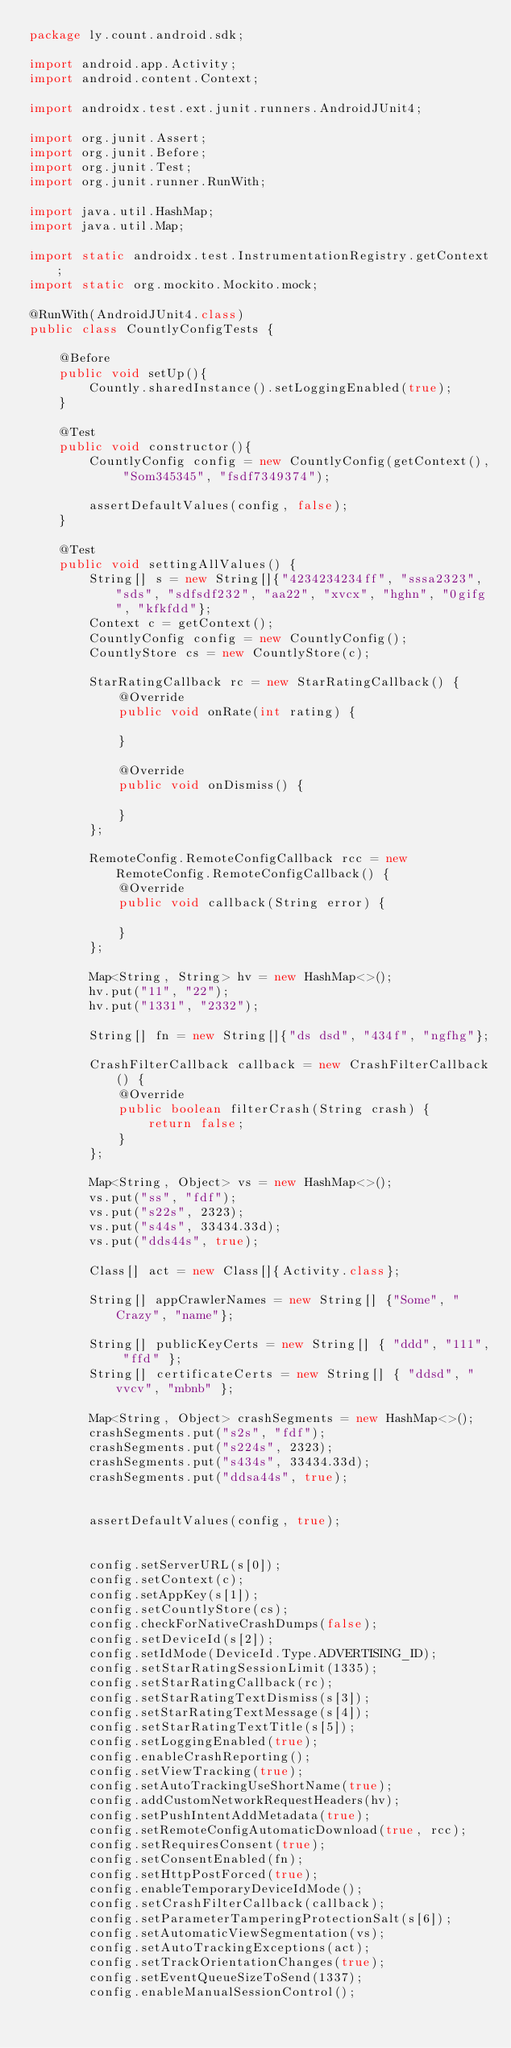Convert code to text. <code><loc_0><loc_0><loc_500><loc_500><_Java_>package ly.count.android.sdk;

import android.app.Activity;
import android.content.Context;

import androidx.test.ext.junit.runners.AndroidJUnit4;

import org.junit.Assert;
import org.junit.Before;
import org.junit.Test;
import org.junit.runner.RunWith;

import java.util.HashMap;
import java.util.Map;

import static androidx.test.InstrumentationRegistry.getContext;
import static org.mockito.Mockito.mock;

@RunWith(AndroidJUnit4.class)
public class CountlyConfigTests {

    @Before
    public void setUp(){
        Countly.sharedInstance().setLoggingEnabled(true);
    }

    @Test
    public void constructor(){
        CountlyConfig config = new CountlyConfig(getContext(), "Som345345", "fsdf7349374");

        assertDefaultValues(config, false);
    }

    @Test
    public void settingAllValues() {
        String[] s = new String[]{"4234234234ff", "sssa2323", "sds", "sdfsdf232", "aa22", "xvcx", "hghn", "0gifg", "kfkfdd"};
        Context c = getContext();
        CountlyConfig config = new CountlyConfig();
        CountlyStore cs = new CountlyStore(c);

        StarRatingCallback rc = new StarRatingCallback() {
            @Override
            public void onRate(int rating) {

            }

            @Override
            public void onDismiss() {

            }
        };

        RemoteConfig.RemoteConfigCallback rcc = new RemoteConfig.RemoteConfigCallback() {
            @Override
            public void callback(String error) {

            }
        };

        Map<String, String> hv = new HashMap<>();
        hv.put("11", "22");
        hv.put("1331", "2332");

        String[] fn = new String[]{"ds dsd", "434f", "ngfhg"};

        CrashFilterCallback callback = new CrashFilterCallback() {
            @Override
            public boolean filterCrash(String crash) {
                return false;
            }
        };

        Map<String, Object> vs = new HashMap<>();
        vs.put("ss", "fdf");
        vs.put("s22s", 2323);
        vs.put("s44s", 33434.33d);
        vs.put("dds44s", true);

        Class[] act = new Class[]{Activity.class};

        String[] appCrawlerNames = new String[] {"Some", "Crazy", "name"};

        String[] publicKeyCerts = new String[] { "ddd", "111", "ffd" };
        String[] certificateCerts = new String[] { "ddsd", "vvcv", "mbnb" };

        Map<String, Object> crashSegments = new HashMap<>();
        crashSegments.put("s2s", "fdf");
        crashSegments.put("s224s", 2323);
        crashSegments.put("s434s", 33434.33d);
        crashSegments.put("ddsa44s", true);


        assertDefaultValues(config, true);


        config.setServerURL(s[0]);
        config.setContext(c);
        config.setAppKey(s[1]);
        config.setCountlyStore(cs);
        config.checkForNativeCrashDumps(false);
        config.setDeviceId(s[2]);
        config.setIdMode(DeviceId.Type.ADVERTISING_ID);
        config.setStarRatingSessionLimit(1335);
        config.setStarRatingCallback(rc);
        config.setStarRatingTextDismiss(s[3]);
        config.setStarRatingTextMessage(s[4]);
        config.setStarRatingTextTitle(s[5]);
        config.setLoggingEnabled(true);
        config.enableCrashReporting();
        config.setViewTracking(true);
        config.setAutoTrackingUseShortName(true);
        config.addCustomNetworkRequestHeaders(hv);
        config.setPushIntentAddMetadata(true);
        config.setRemoteConfigAutomaticDownload(true, rcc);
        config.setRequiresConsent(true);
        config.setConsentEnabled(fn);
        config.setHttpPostForced(true);
        config.enableTemporaryDeviceIdMode();
        config.setCrashFilterCallback(callback);
        config.setParameterTamperingProtectionSalt(s[6]);
        config.setAutomaticViewSegmentation(vs);
        config.setAutoTrackingExceptions(act);
        config.setTrackOrientationChanges(true);
        config.setEventQueueSizeToSend(1337);
        config.enableManualSessionControl();</code> 